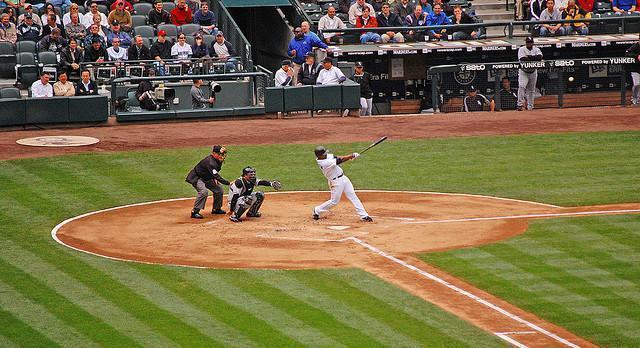Which wood used to make baseball bat?
Select the accurate response from the four choices given to answer the question.
Options: Ash, pine, sandal, maple. Maple. 